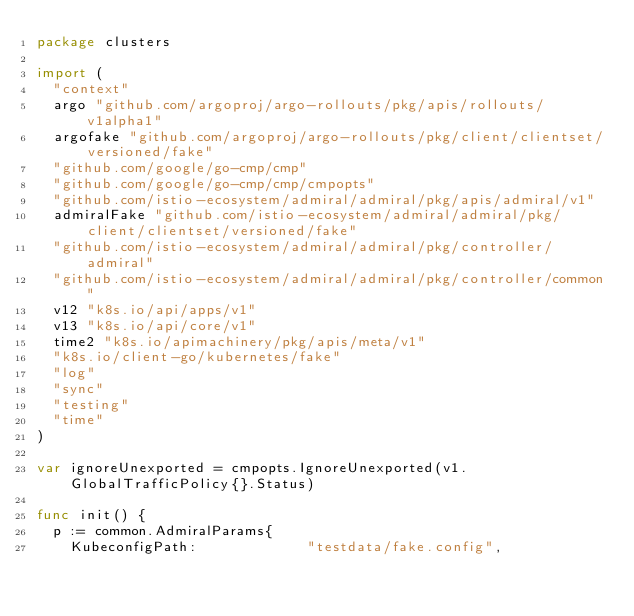Convert code to text. <code><loc_0><loc_0><loc_500><loc_500><_Go_>package clusters

import (
	"context"
	argo "github.com/argoproj/argo-rollouts/pkg/apis/rollouts/v1alpha1"
	argofake "github.com/argoproj/argo-rollouts/pkg/client/clientset/versioned/fake"
	"github.com/google/go-cmp/cmp"
	"github.com/google/go-cmp/cmp/cmpopts"
	"github.com/istio-ecosystem/admiral/admiral/pkg/apis/admiral/v1"
	admiralFake "github.com/istio-ecosystem/admiral/admiral/pkg/client/clientset/versioned/fake"
	"github.com/istio-ecosystem/admiral/admiral/pkg/controller/admiral"
	"github.com/istio-ecosystem/admiral/admiral/pkg/controller/common"
	v12 "k8s.io/api/apps/v1"
	v13 "k8s.io/api/core/v1"
	time2 "k8s.io/apimachinery/pkg/apis/meta/v1"
	"k8s.io/client-go/kubernetes/fake"
	"log"
	"sync"
	"testing"
	"time"
)

var ignoreUnexported = cmpopts.IgnoreUnexported(v1.GlobalTrafficPolicy{}.Status)

func init() {
	p := common.AdmiralParams{
		KubeconfigPath:             "testdata/fake.config",</code> 